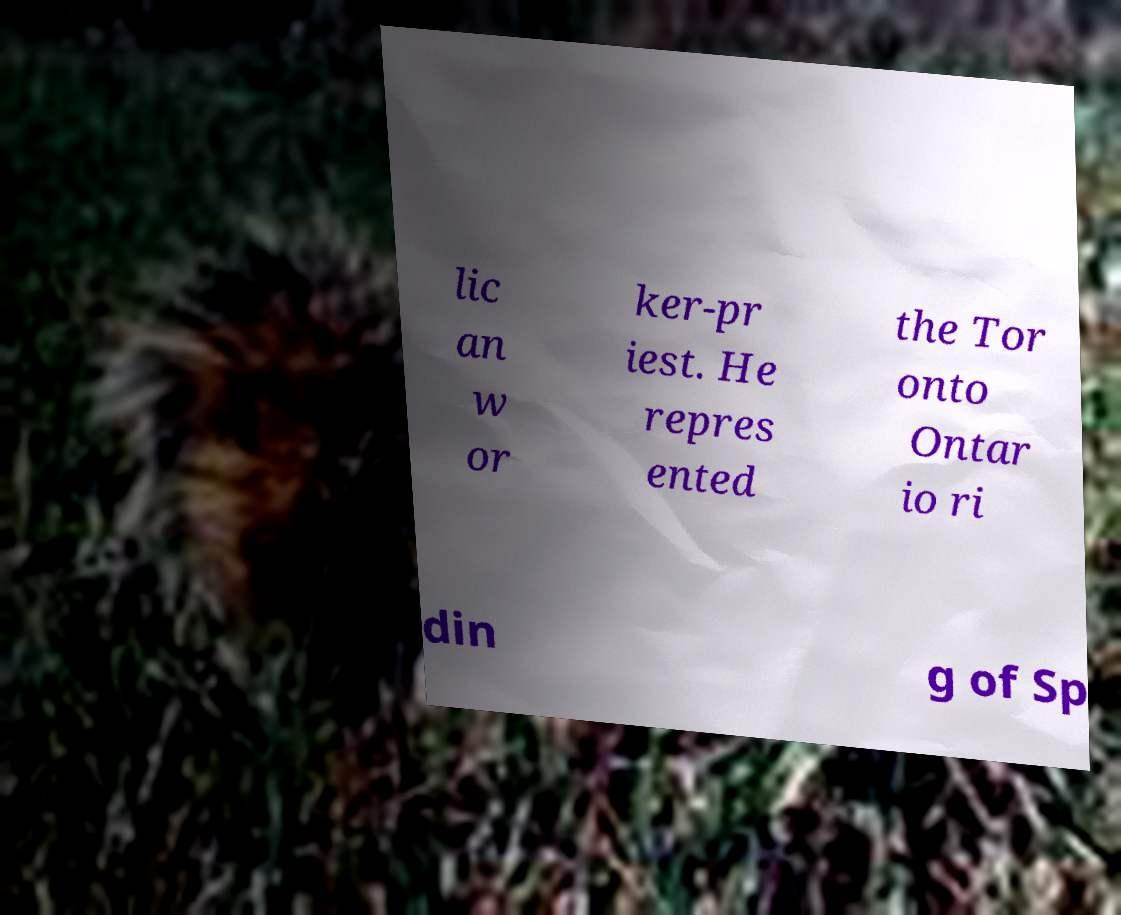Please read and relay the text visible in this image. What does it say? lic an w or ker-pr iest. He repres ented the Tor onto Ontar io ri din g of Sp 